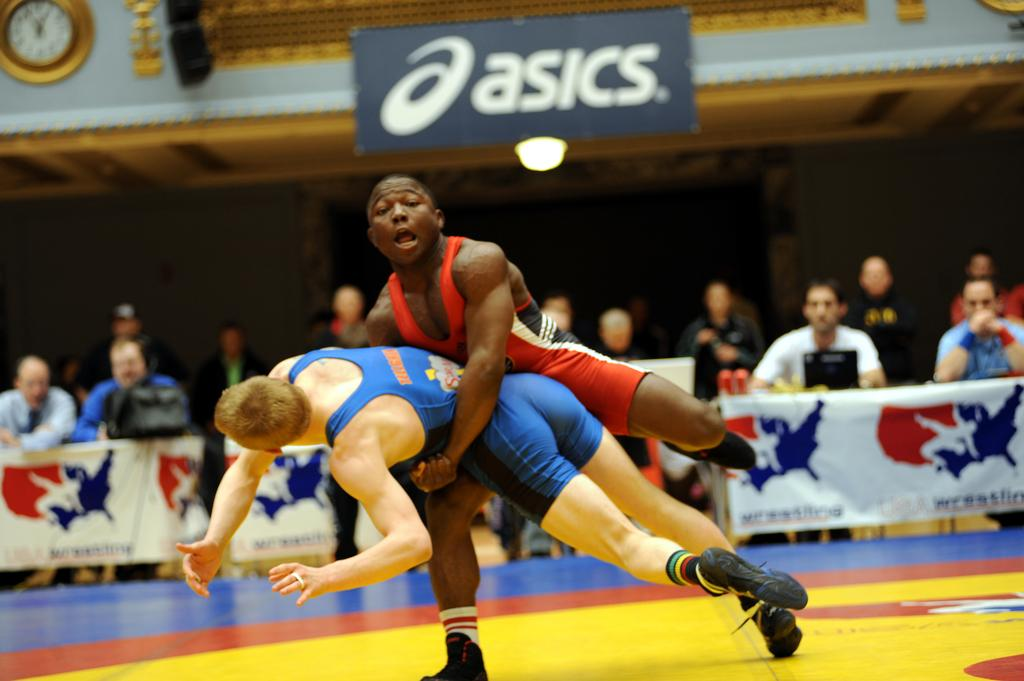Provide a one-sentence caption for the provided image. people watching boys wresting with an asics sign overhead. 